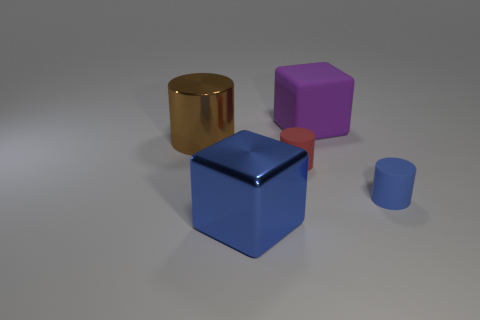Subtract all tiny matte cylinders. How many cylinders are left? 1 Add 1 big red cubes. How many objects exist? 6 Subtract 2 cylinders. How many cylinders are left? 1 Subtract all cylinders. How many objects are left? 2 Subtract all red cylinders. Subtract all green spheres. How many cylinders are left? 2 Subtract all green balls. How many brown blocks are left? 0 Subtract all tiny things. Subtract all large cyan cylinders. How many objects are left? 3 Add 5 matte blocks. How many matte blocks are left? 6 Add 3 big gray blocks. How many big gray blocks exist? 3 Subtract all blue cylinders. How many cylinders are left? 2 